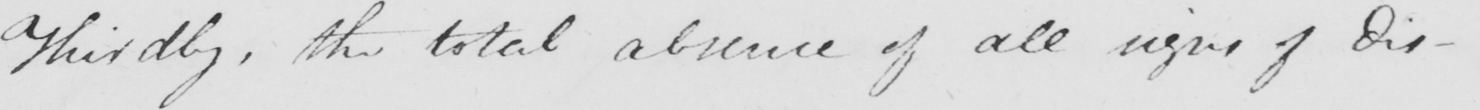What does this handwritten line say? Thirdly , the total absence of all signs of dis- 